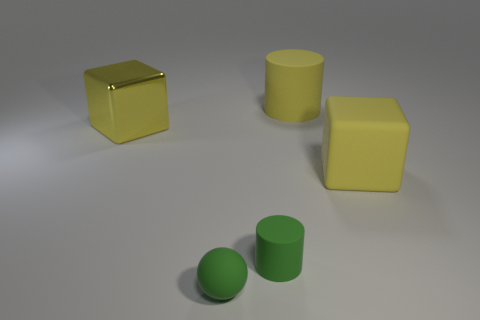There is a yellow rubber object that is to the left of the cube that is right of the yellow cylinder; is there a big rubber cylinder that is on the right side of it?
Your response must be concise. No. There is a tiny thing that is in front of the tiny green rubber cylinder; does it have the same shape as the large yellow shiny thing?
Provide a succinct answer. No. There is a yellow thing that is both left of the large rubber cube and right of the metal thing; how big is it?
Ensure brevity in your answer.  Large. Are there more tiny things that are on the left side of the tiny cylinder than big yellow metallic blocks that are right of the big yellow matte cube?
Provide a short and direct response. Yes. There is a large metal object; is its shape the same as the green matte object that is on the right side of the green matte ball?
Provide a short and direct response. No. There is a large thing that is both on the right side of the big yellow metal object and in front of the large yellow matte cylinder; what color is it?
Make the answer very short. Yellow. Are the big yellow cylinder and the yellow block that is in front of the big metal thing made of the same material?
Your response must be concise. Yes. What is the shape of the small green thing that is made of the same material as the small ball?
Keep it short and to the point. Cylinder. What is the color of the matte thing that is the same size as the ball?
Ensure brevity in your answer.  Green. Does the yellow rubber object in front of the metallic thing have the same size as the green rubber sphere?
Your response must be concise. No. 